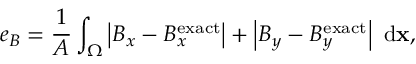Convert formula to latex. <formula><loc_0><loc_0><loc_500><loc_500>e _ { B } = \frac { 1 } { A } \int _ { \Omega } \left | B _ { x } - B _ { x } ^ { e x a c t } \right | + \left | B _ { y } - B _ { y } ^ { e x a c t } \right | \ d x ,</formula> 